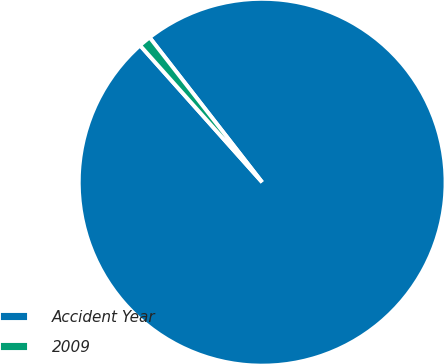Convert chart to OTSL. <chart><loc_0><loc_0><loc_500><loc_500><pie_chart><fcel>Accident Year<fcel>2009<nl><fcel>98.92%<fcel>1.08%<nl></chart> 